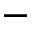Convert formula to latex. <formula><loc_0><loc_0><loc_500><loc_500>^ { - }</formula> 